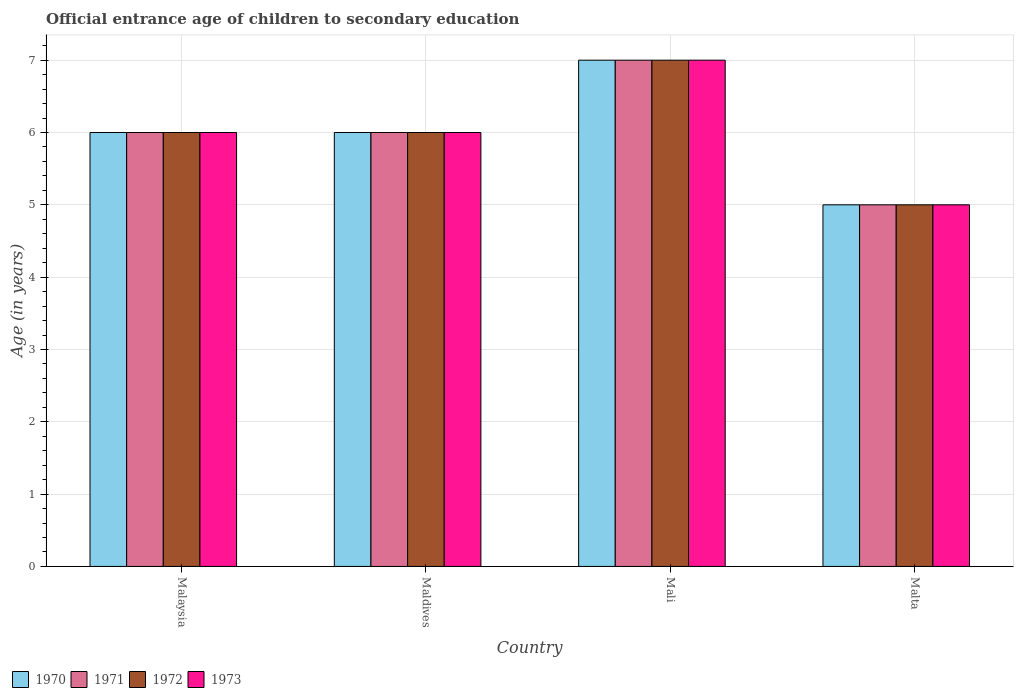How many different coloured bars are there?
Offer a terse response. 4. How many groups of bars are there?
Your answer should be very brief. 4. What is the label of the 4th group of bars from the left?
Keep it short and to the point. Malta. What is the secondary school starting age of children in 1970 in Mali?
Give a very brief answer. 7. Across all countries, what is the maximum secondary school starting age of children in 1972?
Give a very brief answer. 7. In which country was the secondary school starting age of children in 1973 maximum?
Your response must be concise. Mali. In which country was the secondary school starting age of children in 1972 minimum?
Your response must be concise. Malta. What is the total secondary school starting age of children in 1970 in the graph?
Provide a short and direct response. 24. What is the difference between the secondary school starting age of children in 1972 in Malaysia and that in Maldives?
Make the answer very short. 0. What is the average secondary school starting age of children in 1973 per country?
Offer a terse response. 6. What is the difference between the secondary school starting age of children of/in 1970 and secondary school starting age of children of/in 1972 in Malaysia?
Your response must be concise. 0. Is the difference between the secondary school starting age of children in 1970 in Mali and Malta greater than the difference between the secondary school starting age of children in 1972 in Mali and Malta?
Provide a short and direct response. No. In how many countries, is the secondary school starting age of children in 1971 greater than the average secondary school starting age of children in 1971 taken over all countries?
Give a very brief answer. 1. Is it the case that in every country, the sum of the secondary school starting age of children in 1973 and secondary school starting age of children in 1971 is greater than the sum of secondary school starting age of children in 1972 and secondary school starting age of children in 1970?
Keep it short and to the point. No. What does the 3rd bar from the left in Malaysia represents?
Your answer should be very brief. 1972. How many bars are there?
Ensure brevity in your answer.  16. How many countries are there in the graph?
Provide a short and direct response. 4. What is the difference between two consecutive major ticks on the Y-axis?
Make the answer very short. 1. Are the values on the major ticks of Y-axis written in scientific E-notation?
Provide a short and direct response. No. Does the graph contain any zero values?
Your response must be concise. No. Where does the legend appear in the graph?
Your answer should be compact. Bottom left. How many legend labels are there?
Your response must be concise. 4. How are the legend labels stacked?
Provide a succinct answer. Horizontal. What is the title of the graph?
Your answer should be compact. Official entrance age of children to secondary education. What is the label or title of the X-axis?
Provide a short and direct response. Country. What is the label or title of the Y-axis?
Offer a terse response. Age (in years). What is the Age (in years) of 1973 in Malaysia?
Your response must be concise. 6. What is the Age (in years) of 1971 in Maldives?
Your response must be concise. 6. What is the Age (in years) in 1973 in Maldives?
Offer a terse response. 6. What is the Age (in years) of 1971 in Mali?
Offer a terse response. 7. What is the Age (in years) in 1971 in Malta?
Ensure brevity in your answer.  5. What is the Age (in years) of 1972 in Malta?
Offer a terse response. 5. What is the Age (in years) in 1973 in Malta?
Provide a short and direct response. 5. Across all countries, what is the maximum Age (in years) of 1970?
Your answer should be compact. 7. Across all countries, what is the maximum Age (in years) in 1971?
Give a very brief answer. 7. Across all countries, what is the maximum Age (in years) in 1973?
Provide a succinct answer. 7. Across all countries, what is the minimum Age (in years) in 1972?
Give a very brief answer. 5. What is the difference between the Age (in years) in 1970 in Malaysia and that in Maldives?
Offer a very short reply. 0. What is the difference between the Age (in years) in 1972 in Malaysia and that in Maldives?
Make the answer very short. 0. What is the difference between the Age (in years) in 1970 in Malaysia and that in Mali?
Provide a short and direct response. -1. What is the difference between the Age (in years) in 1971 in Malaysia and that in Mali?
Ensure brevity in your answer.  -1. What is the difference between the Age (in years) in 1972 in Malaysia and that in Malta?
Give a very brief answer. 1. What is the difference between the Age (in years) in 1973 in Malaysia and that in Malta?
Your answer should be compact. 1. What is the difference between the Age (in years) of 1971 in Maldives and that in Mali?
Provide a short and direct response. -1. What is the difference between the Age (in years) of 1972 in Maldives and that in Mali?
Your answer should be compact. -1. What is the difference between the Age (in years) in 1970 in Maldives and that in Malta?
Offer a terse response. 1. What is the difference between the Age (in years) of 1973 in Maldives and that in Malta?
Provide a succinct answer. 1. What is the difference between the Age (in years) of 1970 in Mali and that in Malta?
Provide a short and direct response. 2. What is the difference between the Age (in years) of 1970 in Malaysia and the Age (in years) of 1971 in Maldives?
Your answer should be very brief. 0. What is the difference between the Age (in years) of 1970 in Malaysia and the Age (in years) of 1972 in Maldives?
Your answer should be very brief. 0. What is the difference between the Age (in years) of 1970 in Malaysia and the Age (in years) of 1973 in Maldives?
Keep it short and to the point. 0. What is the difference between the Age (in years) of 1971 in Malaysia and the Age (in years) of 1973 in Maldives?
Offer a very short reply. 0. What is the difference between the Age (in years) of 1972 in Malaysia and the Age (in years) of 1973 in Maldives?
Provide a short and direct response. 0. What is the difference between the Age (in years) in 1970 in Malaysia and the Age (in years) in 1973 in Mali?
Ensure brevity in your answer.  -1. What is the difference between the Age (in years) in 1971 in Malaysia and the Age (in years) in 1973 in Mali?
Give a very brief answer. -1. What is the difference between the Age (in years) of 1972 in Malaysia and the Age (in years) of 1973 in Mali?
Your answer should be very brief. -1. What is the difference between the Age (in years) in 1970 in Malaysia and the Age (in years) in 1973 in Malta?
Provide a short and direct response. 1. What is the difference between the Age (in years) of 1970 in Maldives and the Age (in years) of 1971 in Mali?
Your response must be concise. -1. What is the difference between the Age (in years) in 1970 in Maldives and the Age (in years) in 1972 in Mali?
Ensure brevity in your answer.  -1. What is the difference between the Age (in years) in 1972 in Maldives and the Age (in years) in 1973 in Mali?
Your response must be concise. -1. What is the difference between the Age (in years) of 1971 in Maldives and the Age (in years) of 1973 in Malta?
Provide a short and direct response. 1. What is the difference between the Age (in years) of 1972 in Maldives and the Age (in years) of 1973 in Malta?
Provide a short and direct response. 1. What is the difference between the Age (in years) in 1970 in Mali and the Age (in years) in 1971 in Malta?
Keep it short and to the point. 2. What is the difference between the Age (in years) in 1970 in Mali and the Age (in years) in 1972 in Malta?
Make the answer very short. 2. What is the difference between the Age (in years) of 1970 in Mali and the Age (in years) of 1973 in Malta?
Make the answer very short. 2. What is the average Age (in years) in 1971 per country?
Provide a short and direct response. 6. What is the average Age (in years) in 1972 per country?
Your answer should be very brief. 6. What is the average Age (in years) in 1973 per country?
Offer a terse response. 6. What is the difference between the Age (in years) of 1970 and Age (in years) of 1972 in Malaysia?
Your response must be concise. 0. What is the difference between the Age (in years) in 1970 and Age (in years) in 1973 in Malaysia?
Ensure brevity in your answer.  0. What is the difference between the Age (in years) in 1971 and Age (in years) in 1972 in Malaysia?
Keep it short and to the point. 0. What is the difference between the Age (in years) of 1971 and Age (in years) of 1973 in Malaysia?
Make the answer very short. 0. What is the difference between the Age (in years) in 1970 and Age (in years) in 1971 in Maldives?
Keep it short and to the point. 0. What is the difference between the Age (in years) of 1971 and Age (in years) of 1972 in Maldives?
Offer a terse response. 0. What is the difference between the Age (in years) in 1972 and Age (in years) in 1973 in Maldives?
Make the answer very short. 0. What is the difference between the Age (in years) of 1970 and Age (in years) of 1973 in Mali?
Your answer should be compact. 0. What is the difference between the Age (in years) in 1971 and Age (in years) in 1973 in Mali?
Your response must be concise. 0. What is the difference between the Age (in years) of 1971 and Age (in years) of 1973 in Malta?
Keep it short and to the point. 0. What is the ratio of the Age (in years) of 1970 in Malaysia to that in Maldives?
Keep it short and to the point. 1. What is the ratio of the Age (in years) of 1971 in Malaysia to that in Maldives?
Your response must be concise. 1. What is the ratio of the Age (in years) of 1971 in Malaysia to that in Mali?
Your answer should be compact. 0.86. What is the ratio of the Age (in years) of 1973 in Malaysia to that in Malta?
Your answer should be compact. 1.2. What is the ratio of the Age (in years) in 1971 in Maldives to that in Mali?
Ensure brevity in your answer.  0.86. What is the ratio of the Age (in years) in 1973 in Maldives to that in Mali?
Your response must be concise. 0.86. What is the ratio of the Age (in years) of 1970 in Maldives to that in Malta?
Offer a very short reply. 1.2. What is the ratio of the Age (in years) in 1973 in Maldives to that in Malta?
Ensure brevity in your answer.  1.2. What is the ratio of the Age (in years) of 1970 in Mali to that in Malta?
Provide a short and direct response. 1.4. What is the ratio of the Age (in years) in 1971 in Mali to that in Malta?
Your answer should be compact. 1.4. What is the difference between the highest and the second highest Age (in years) of 1972?
Give a very brief answer. 1. What is the difference between the highest and the lowest Age (in years) in 1970?
Your response must be concise. 2. What is the difference between the highest and the lowest Age (in years) in 1971?
Your response must be concise. 2. What is the difference between the highest and the lowest Age (in years) in 1973?
Provide a succinct answer. 2. 